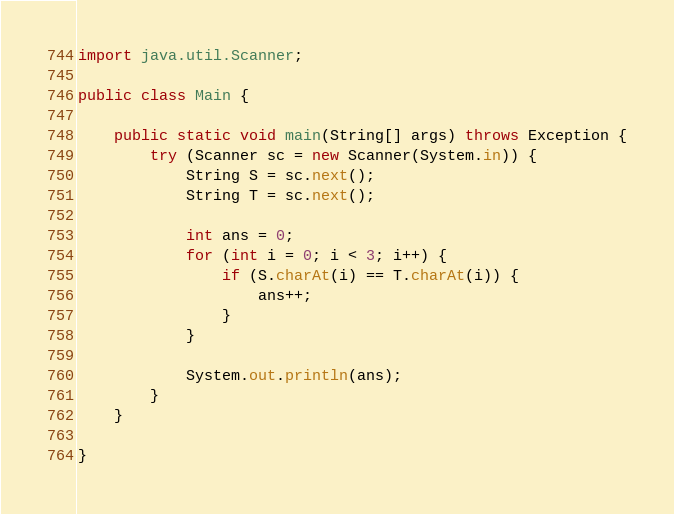<code> <loc_0><loc_0><loc_500><loc_500><_Java_>import java.util.Scanner;

public class Main {

    public static void main(String[] args) throws Exception {
        try (Scanner sc = new Scanner(System.in)) {
            String S = sc.next();
            String T = sc.next();

            int ans = 0;
            for (int i = 0; i < 3; i++) {
                if (S.charAt(i) == T.charAt(i)) {
                    ans++;
                }
            }

            System.out.println(ans);
        }
    }

}
</code> 